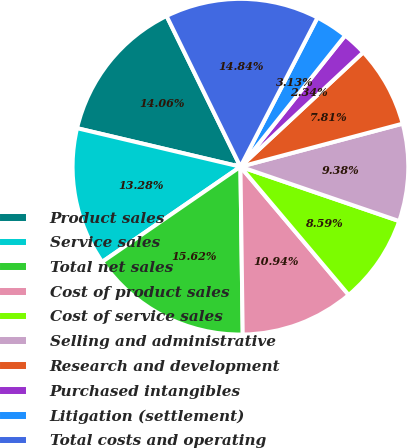<chart> <loc_0><loc_0><loc_500><loc_500><pie_chart><fcel>Product sales<fcel>Service sales<fcel>Total net sales<fcel>Cost of product sales<fcel>Cost of service sales<fcel>Selling and administrative<fcel>Research and development<fcel>Purchased intangibles<fcel>Litigation (settlement)<fcel>Total costs and operating<nl><fcel>14.06%<fcel>13.28%<fcel>15.62%<fcel>10.94%<fcel>8.59%<fcel>9.38%<fcel>7.81%<fcel>2.34%<fcel>3.13%<fcel>14.84%<nl></chart> 